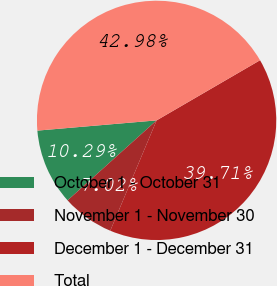Convert chart to OTSL. <chart><loc_0><loc_0><loc_500><loc_500><pie_chart><fcel>October 1 - October 31<fcel>November 1 - November 30<fcel>December 1 - December 31<fcel>Total<nl><fcel>10.29%<fcel>7.02%<fcel>39.71%<fcel>42.98%<nl></chart> 